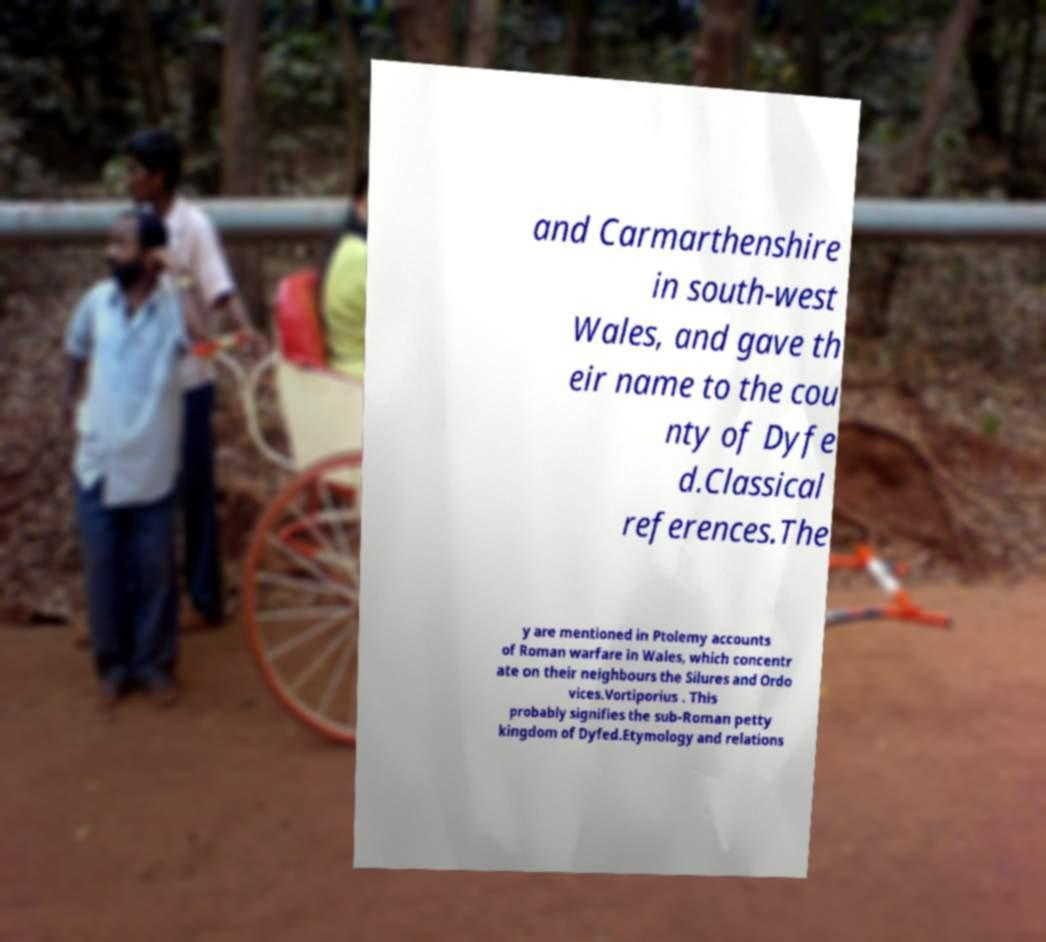For documentation purposes, I need the text within this image transcribed. Could you provide that? and Carmarthenshire in south-west Wales, and gave th eir name to the cou nty of Dyfe d.Classical references.The y are mentioned in Ptolemy accounts of Roman warfare in Wales, which concentr ate on their neighbours the Silures and Ordo vices.Vortiporius . This probably signifies the sub-Roman petty kingdom of Dyfed.Etymology and relations 